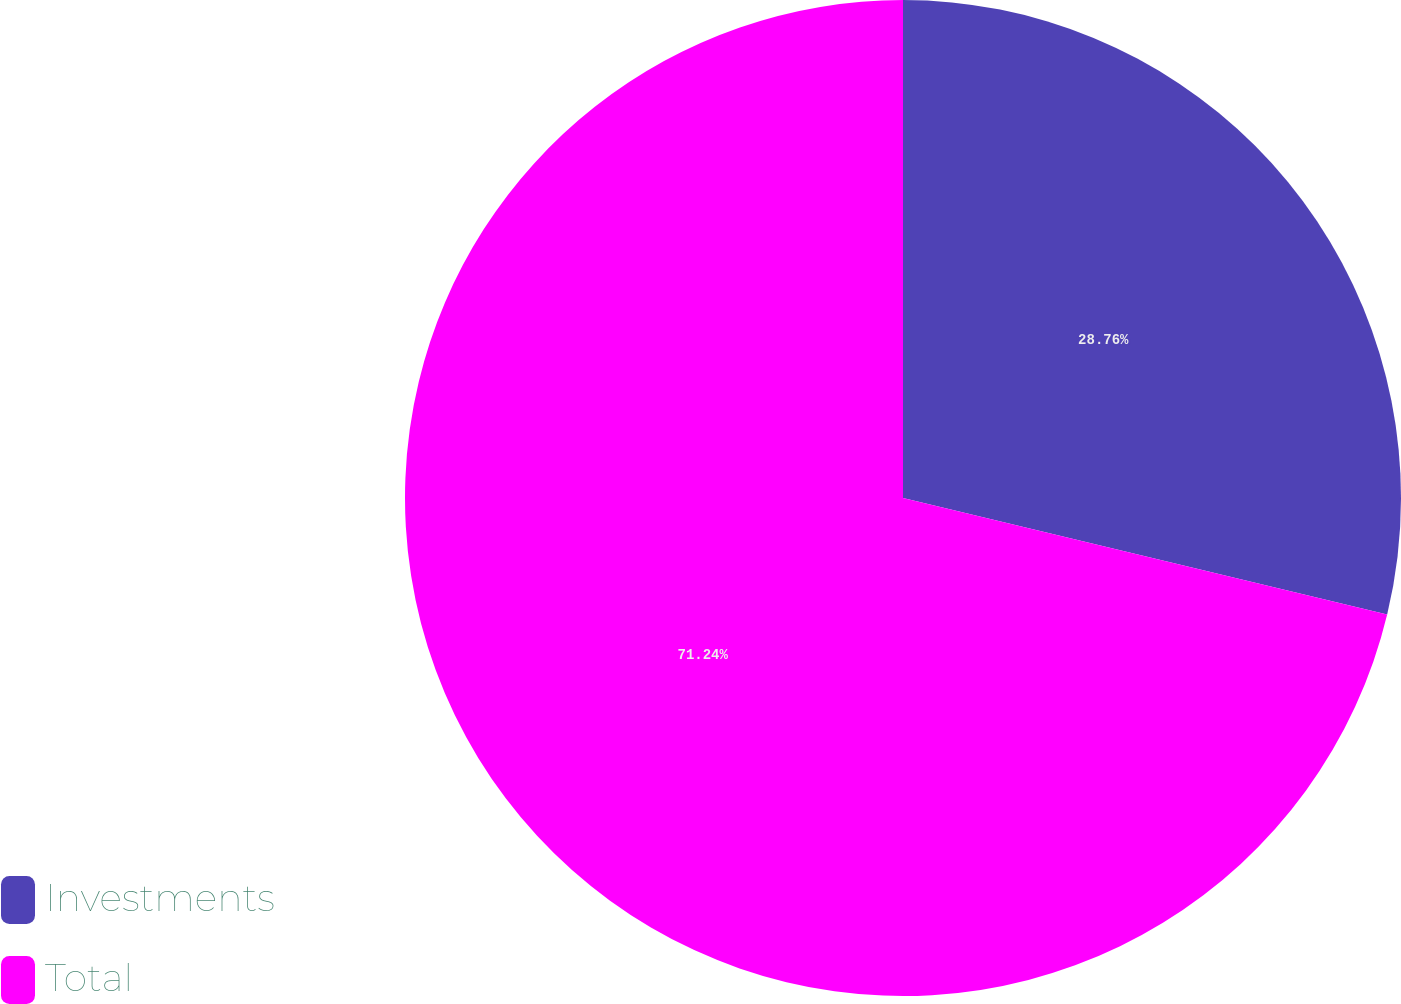<chart> <loc_0><loc_0><loc_500><loc_500><pie_chart><fcel>Investments<fcel>Total<nl><fcel>28.76%<fcel>71.24%<nl></chart> 